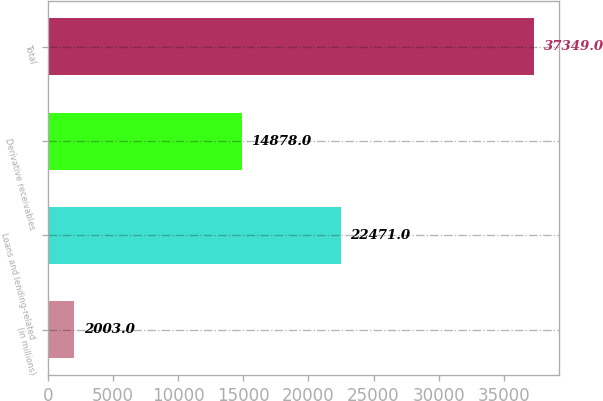Convert chart to OTSL. <chart><loc_0><loc_0><loc_500><loc_500><bar_chart><fcel>(in millions)<fcel>Loans and lending-related<fcel>Derivative receivables<fcel>Total<nl><fcel>2003<fcel>22471<fcel>14878<fcel>37349<nl></chart> 